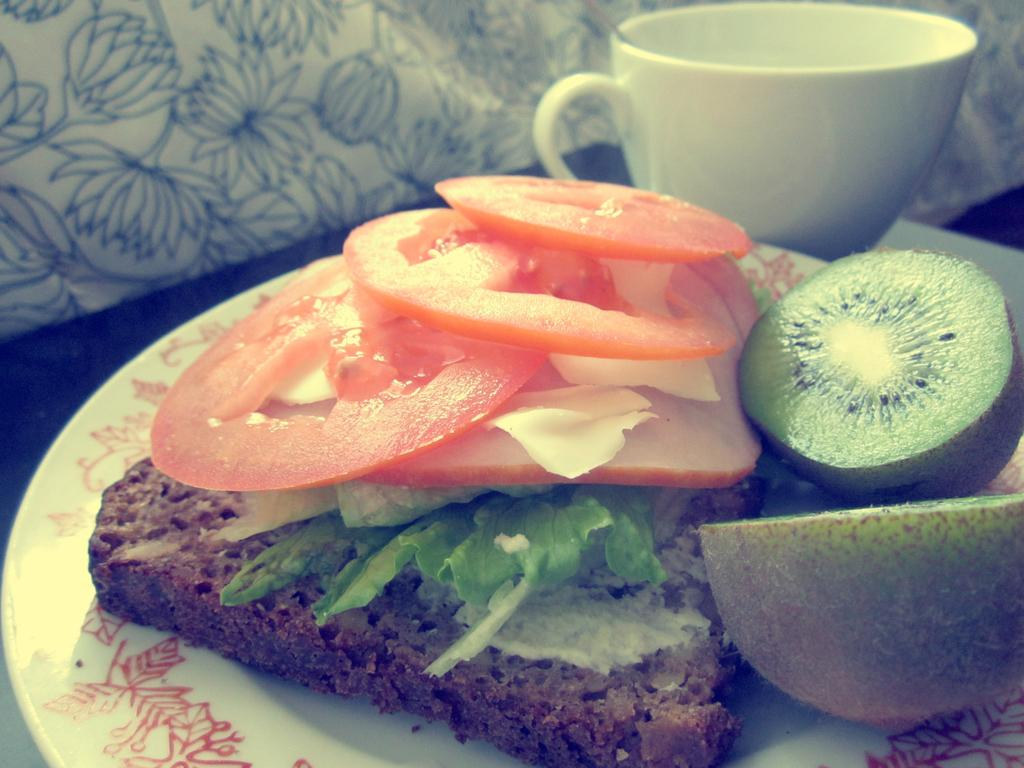What is on the plate in the image? There is a food item on a plate in the image. What is beside the plate on the table? There is a cup beside the plate in the image. What is the surface on which the plate and cup are placed? The plate and cup are placed on a surface that resembles a table. Can you describe any other objects visible in the image? There are other objects visible in the image, but their specific details are not mentioned in the provided facts. How many sisters are sitting at the table in the image? There is no mention of sisters or anyone sitting at the table in the provided facts, so we cannot answer this question. 